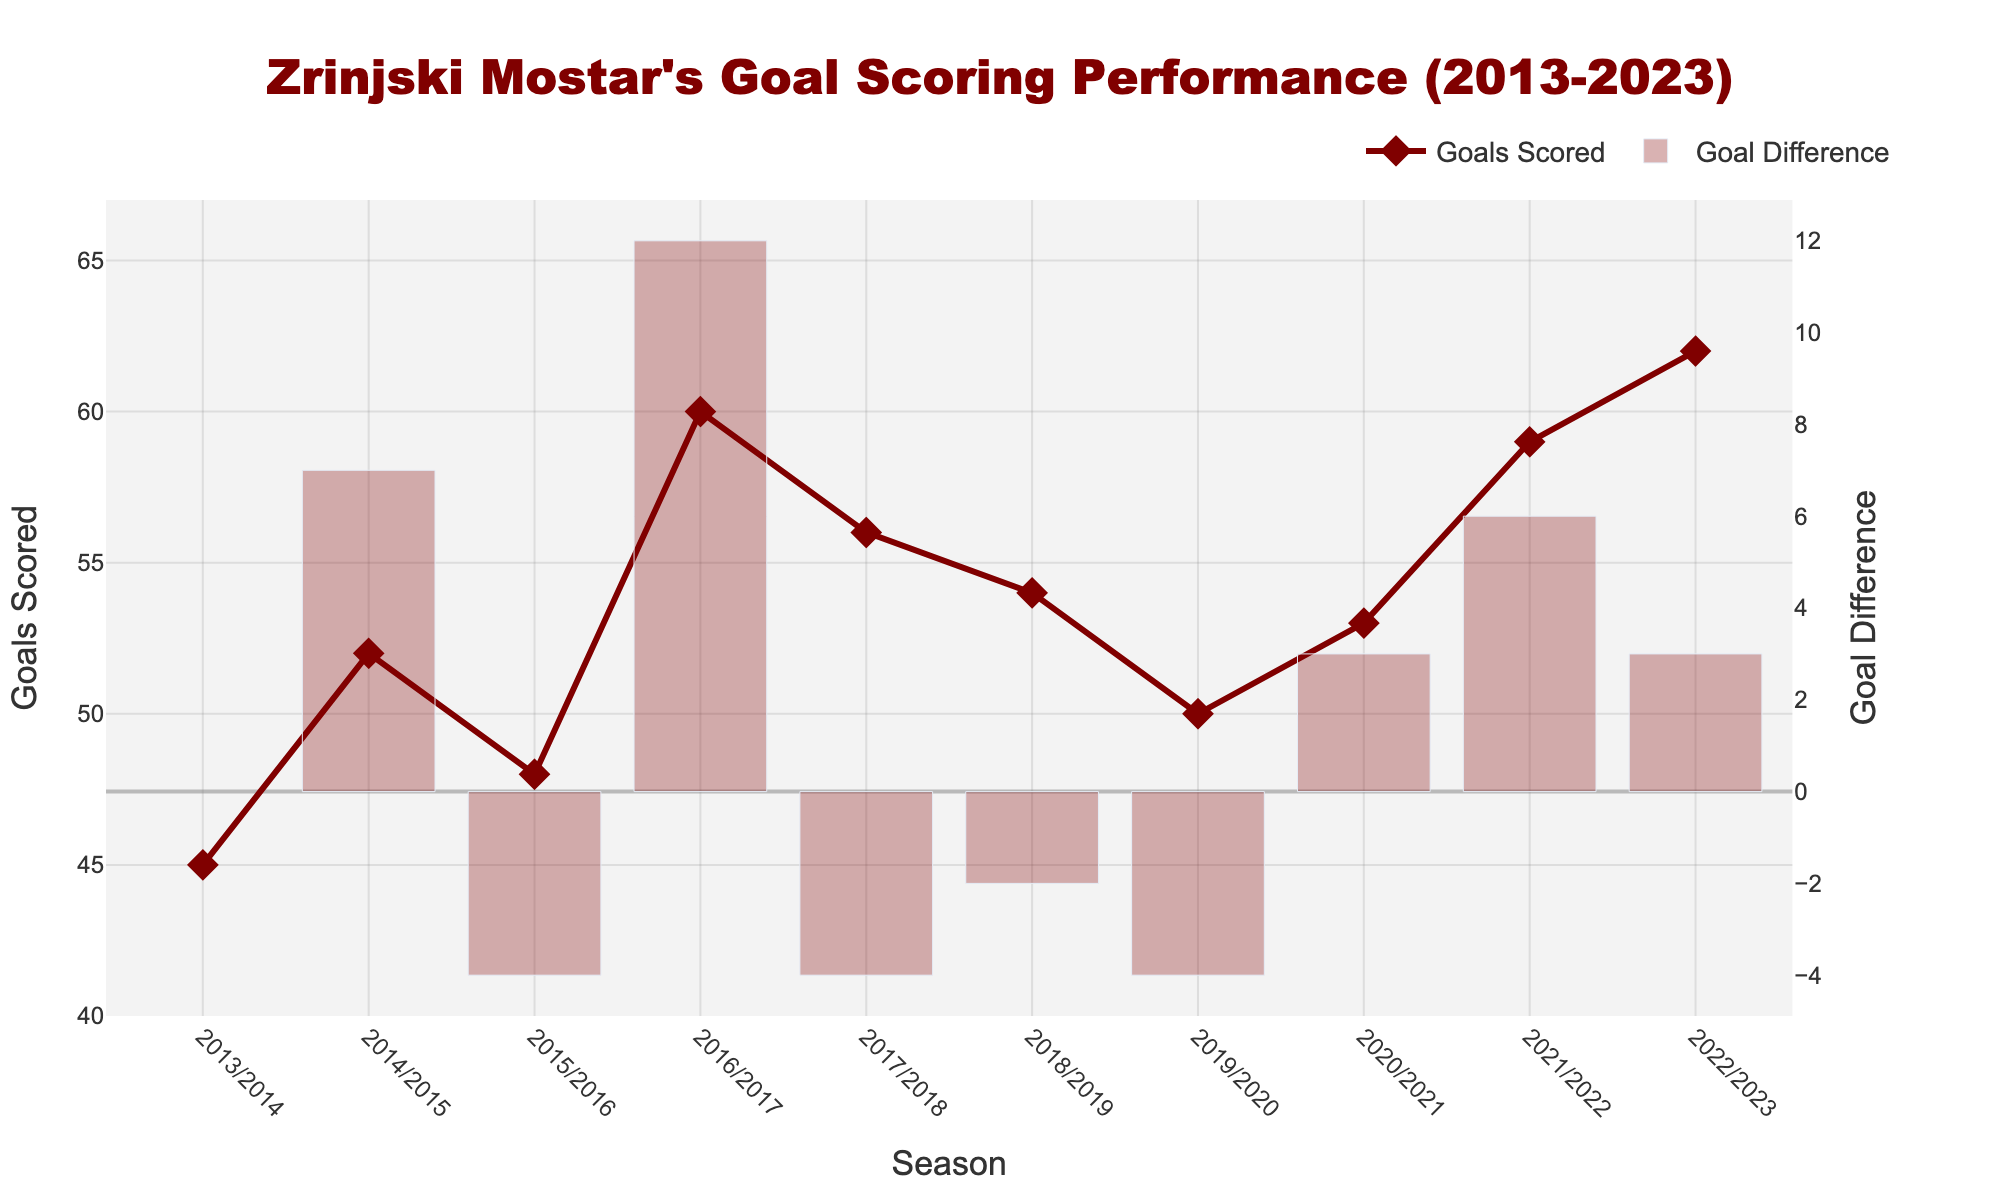What is the title of the figure? The title is usually located at the top of the figure, providing a summary of what the plot represents. In this case, the title should be visible at the top, and it reads "Zrinjski Mostar's Goal Scoring Performance (2013-2023)"
Answer: Zrinjski Mostar's Goal Scoring Performance (2013-2023) How many seasons are represented in the plot? Seasons are marked on the x-axis, from 2013/2014 to 2022/2023. Counting these intervals, we find that there are a total of 10 seasons represented.
Answer: 10 In which season did Zrinjski Mostar score the most goals? By examining the 'Goals Scored' line plot, the highest point indicates the peak goal-scoring season. In this case, the highest point is in the 2022/2023 season with 62 goals.
Answer: 2022/2023 What is the lowest number of goals scored in a season? Looking at the lowest point of the 'Goals Scored' line plot, the minimum value is reached in the 2013/2014 season with 45 goals.
Answer: 45 What is the difference in the total number of goals scored between the 2013/2014 and 2022/2023 seasons? To find this, subtract the goals scored in 2013/2014 (45) from the goals scored in 2022/2023 (62).
Answer: 17 Which seasons had a negative goal difference compared to their previous seasons? Negative goal differences are marked in the bar plot with bars beneath the zero line. These can be identified in the seasons 2015/2016, 2017/2018, and 2019/2020.
Answer: 2015/2016, 2017/2018, 2019/2020 In how many seasons was the goal difference positive compared to the previous season? We count the bars on the bar plot that are above the zero line. Positive goal differences are found in the seasons 2014/2015, 2016/2017, 2018/2019, 2020/2021, 2021/2022, and 2022/2023. Thus, there are 6 positive goal difference seasons.
Answer: 6 Which consecutive seasons saw the largest increase in goals scored? To find this, look for the tallest positive bar in the 'Goal Difference' plot. The largest increase is seen between the 2015/2016 and 2016/2017 seasons, where the difference is +12 goals.
Answer: 2015/2016 to 2016/2017 What is the average number of goals scored per season over the decade? Sum all the goals scored from each season (45 + 52 + 48 + 60 + 56 + 54 + 50 + 53 + 59 + 62) and then divide by the number of seasons (10). The sum is 539, thus the average is 539/10 = 53.9
Answer: 53.9 